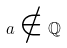Convert formula to latex. <formula><loc_0><loc_0><loc_500><loc_500>a \notin \mathbb { Q }</formula> 